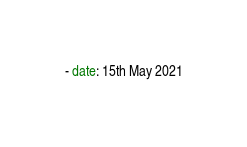Convert code to text. <code><loc_0><loc_0><loc_500><loc_500><_YAML_>- date: 15th May 2021</code> 